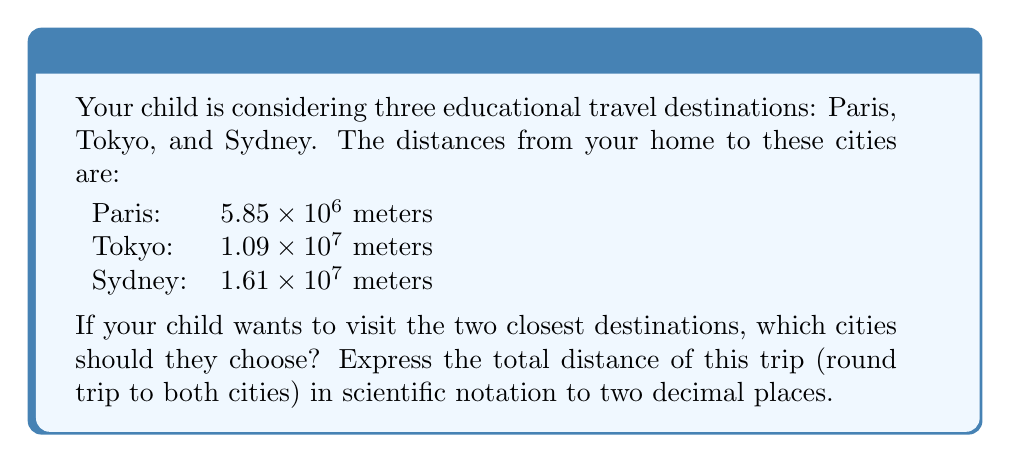Could you help me with this problem? 1. First, let's order the distances from shortest to longest:
   Paris: $5.85 \times 10^6$ m
   Tokyo: $1.09 \times 10^7$ m
   Sydney: $1.61 \times 10^7$ m

2. The two closest destinations are Paris and Tokyo.

3. Calculate the total distance for a round trip to both cities:
   - To Paris and back: $2 \times (5.85 \times 10^6)$ m
   - To Tokyo and back: $2 \times (1.09 \times 10^7)$ m

4. Add these distances:
   $$(2 \times 5.85 \times 10^6) + (2 \times 1.09 \times 10^7)$$
   $$= 11.7 \times 10^6 + 21.8 \times 10^6$$
   $$= 33.5 \times 10^6$$

5. Convert to scientific notation with two decimal places:
   $$33.5 \times 10^6 = 3.35 \times 10^7$$ meters
Answer: Paris and Tokyo; $3.35 \times 10^7$ m 